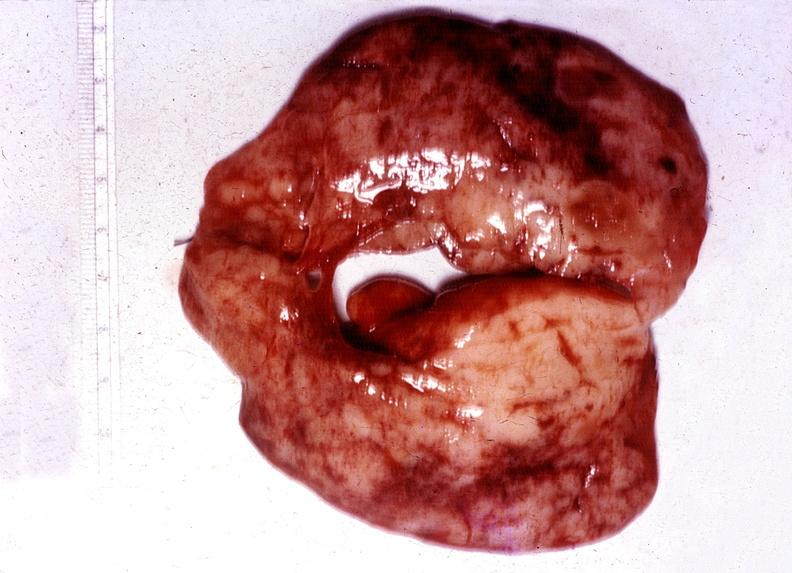what does this image show?
Answer the question using a single word or phrase. Thyroid 